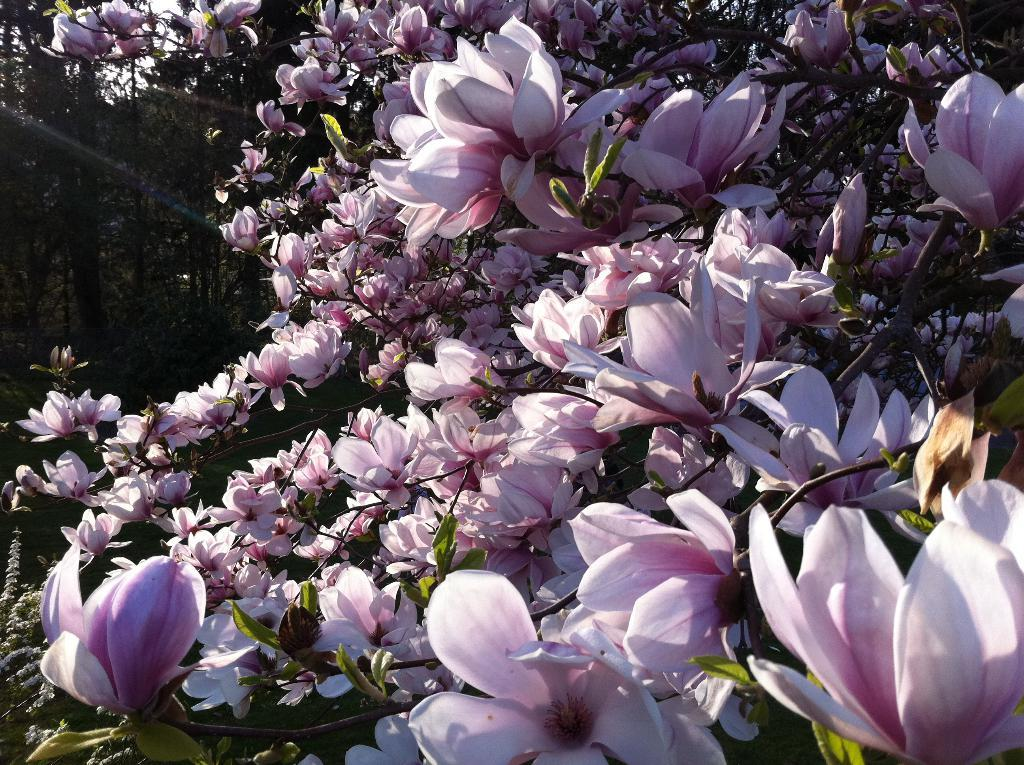What type of vegetation can be seen in the image? There are flowers on plants, other plants, and trees in the image. Can you describe the different types of plants in the image? The image shows flowers on plants, other plants, and trees. What is the primary focus of the image? The primary focus of the image is the vegetation, including flowers, plants, and trees. How many parents can be seen in the image? There are no parents present in the image; it features vegetation, including flowers, plants, and trees. What type of stitch is used to create the flowers in the image? The image is a photograph, not a drawing or embroidery, so there is no stitching involved in creating the flowers. 